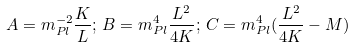Convert formula to latex. <formula><loc_0><loc_0><loc_500><loc_500>A = m _ { P l } ^ { - 2 } \frac { K } { L } ; \, B = m _ { P l } ^ { 4 } \frac { L ^ { 2 } } { 4 K } ; \, C = m _ { P l } ^ { 4 } ( \frac { L ^ { 2 } } { 4 K } - M )</formula> 